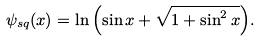<formula> <loc_0><loc_0><loc_500><loc_500>\psi _ { s q } ( x ) = \ln { \left ( \sin { x } + \sqrt { 1 + \sin ^ { 2 } { x } } \right ) } .</formula> 